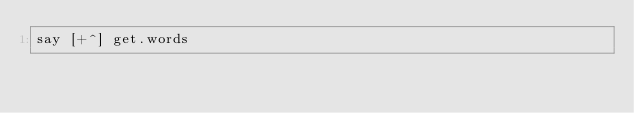<code> <loc_0><loc_0><loc_500><loc_500><_Perl_>say [+^] get.words</code> 